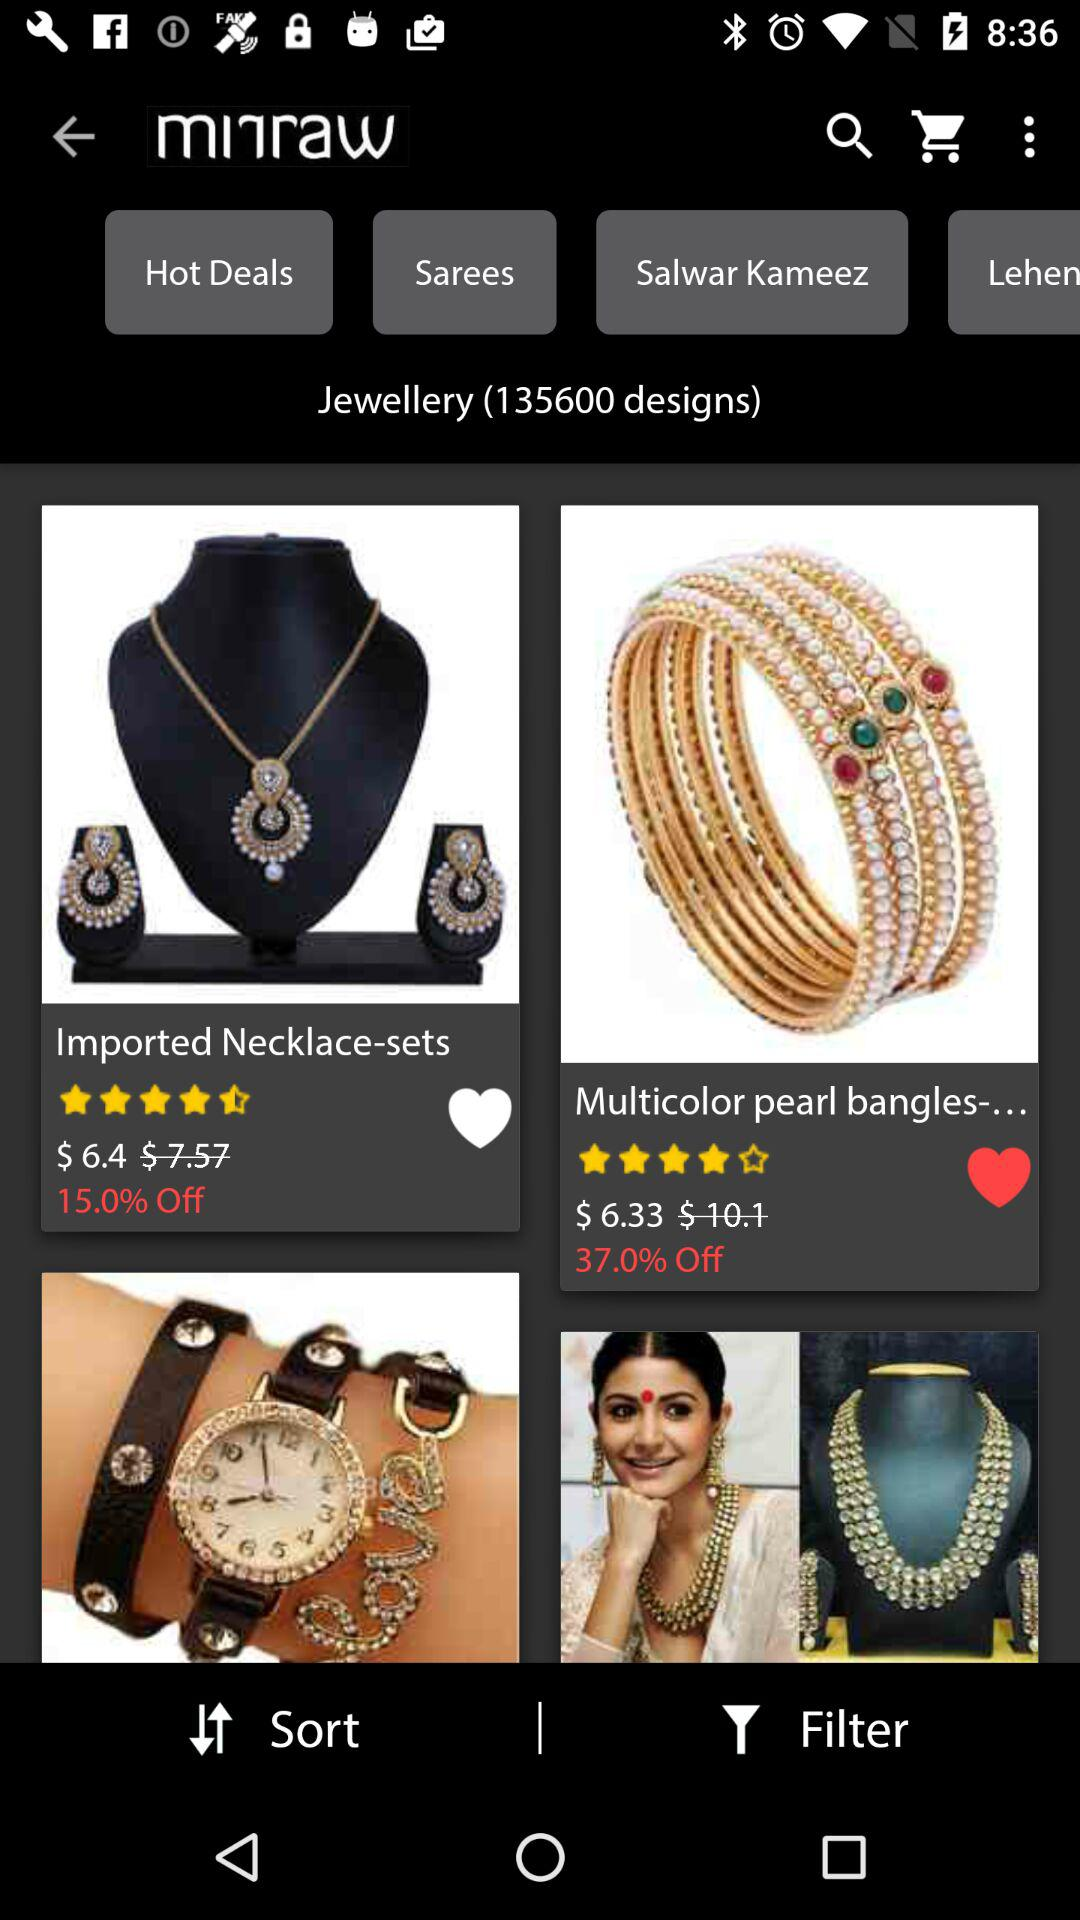How much of the percentage is off on the necklace? The percentage off on the necklace is 15. 